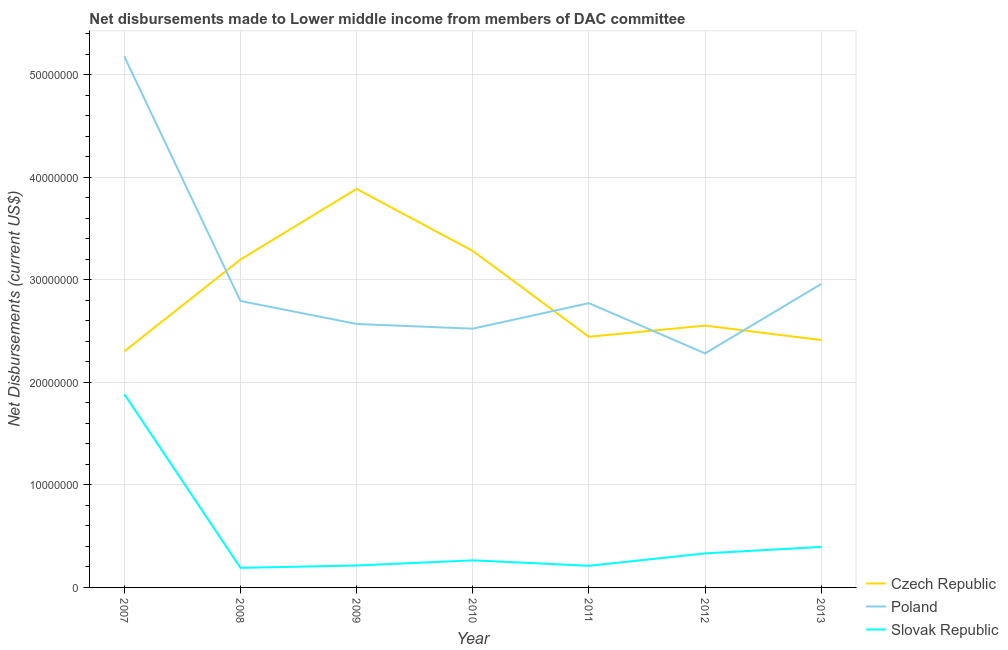Does the line corresponding to net disbursements made by poland intersect with the line corresponding to net disbursements made by slovak republic?
Ensure brevity in your answer.  No. Is the number of lines equal to the number of legend labels?
Ensure brevity in your answer.  Yes. What is the net disbursements made by slovak republic in 2012?
Provide a short and direct response. 3.32e+06. Across all years, what is the maximum net disbursements made by slovak republic?
Offer a very short reply. 1.88e+07. Across all years, what is the minimum net disbursements made by poland?
Ensure brevity in your answer.  2.28e+07. In which year was the net disbursements made by czech republic maximum?
Offer a very short reply. 2009. What is the total net disbursements made by poland in the graph?
Your answer should be compact. 2.11e+08. What is the difference between the net disbursements made by slovak republic in 2007 and that in 2011?
Keep it short and to the point. 1.67e+07. What is the difference between the net disbursements made by slovak republic in 2010 and the net disbursements made by poland in 2009?
Ensure brevity in your answer.  -2.30e+07. What is the average net disbursements made by slovak republic per year?
Your answer should be compact. 4.99e+06. In the year 2012, what is the difference between the net disbursements made by czech republic and net disbursements made by poland?
Make the answer very short. 2.71e+06. What is the ratio of the net disbursements made by czech republic in 2011 to that in 2012?
Your response must be concise. 0.96. Is the difference between the net disbursements made by poland in 2009 and 2012 greater than the difference between the net disbursements made by slovak republic in 2009 and 2012?
Offer a very short reply. Yes. What is the difference between the highest and the second highest net disbursements made by poland?
Ensure brevity in your answer.  2.22e+07. What is the difference between the highest and the lowest net disbursements made by czech republic?
Keep it short and to the point. 1.58e+07. In how many years, is the net disbursements made by czech republic greater than the average net disbursements made by czech republic taken over all years?
Offer a terse response. 3. Is it the case that in every year, the sum of the net disbursements made by czech republic and net disbursements made by poland is greater than the net disbursements made by slovak republic?
Offer a very short reply. Yes. Does the net disbursements made by poland monotonically increase over the years?
Provide a succinct answer. No. Is the net disbursements made by poland strictly greater than the net disbursements made by czech republic over the years?
Provide a succinct answer. No. Are the values on the major ticks of Y-axis written in scientific E-notation?
Provide a succinct answer. No. Does the graph contain grids?
Keep it short and to the point. Yes. What is the title of the graph?
Give a very brief answer. Net disbursements made to Lower middle income from members of DAC committee. What is the label or title of the X-axis?
Offer a terse response. Year. What is the label or title of the Y-axis?
Ensure brevity in your answer.  Net Disbursements (current US$). What is the Net Disbursements (current US$) of Czech Republic in 2007?
Your response must be concise. 2.30e+07. What is the Net Disbursements (current US$) in Poland in 2007?
Give a very brief answer. 5.18e+07. What is the Net Disbursements (current US$) in Slovak Republic in 2007?
Provide a succinct answer. 1.88e+07. What is the Net Disbursements (current US$) of Czech Republic in 2008?
Provide a short and direct response. 3.20e+07. What is the Net Disbursements (current US$) in Poland in 2008?
Provide a succinct answer. 2.79e+07. What is the Net Disbursements (current US$) of Slovak Republic in 2008?
Your answer should be very brief. 1.91e+06. What is the Net Disbursements (current US$) in Czech Republic in 2009?
Give a very brief answer. 3.89e+07. What is the Net Disbursements (current US$) of Poland in 2009?
Provide a succinct answer. 2.57e+07. What is the Net Disbursements (current US$) of Slovak Republic in 2009?
Your answer should be compact. 2.14e+06. What is the Net Disbursements (current US$) of Czech Republic in 2010?
Ensure brevity in your answer.  3.28e+07. What is the Net Disbursements (current US$) of Poland in 2010?
Provide a succinct answer. 2.52e+07. What is the Net Disbursements (current US$) in Slovak Republic in 2010?
Provide a short and direct response. 2.64e+06. What is the Net Disbursements (current US$) in Czech Republic in 2011?
Provide a succinct answer. 2.44e+07. What is the Net Disbursements (current US$) of Poland in 2011?
Your answer should be compact. 2.77e+07. What is the Net Disbursements (current US$) in Slovak Republic in 2011?
Make the answer very short. 2.11e+06. What is the Net Disbursements (current US$) in Czech Republic in 2012?
Your answer should be very brief. 2.55e+07. What is the Net Disbursements (current US$) of Poland in 2012?
Make the answer very short. 2.28e+07. What is the Net Disbursements (current US$) in Slovak Republic in 2012?
Provide a short and direct response. 3.32e+06. What is the Net Disbursements (current US$) in Czech Republic in 2013?
Give a very brief answer. 2.41e+07. What is the Net Disbursements (current US$) in Poland in 2013?
Make the answer very short. 2.96e+07. What is the Net Disbursements (current US$) in Slovak Republic in 2013?
Provide a short and direct response. 3.95e+06. Across all years, what is the maximum Net Disbursements (current US$) of Czech Republic?
Keep it short and to the point. 3.89e+07. Across all years, what is the maximum Net Disbursements (current US$) of Poland?
Offer a terse response. 5.18e+07. Across all years, what is the maximum Net Disbursements (current US$) of Slovak Republic?
Provide a short and direct response. 1.88e+07. Across all years, what is the minimum Net Disbursements (current US$) of Czech Republic?
Keep it short and to the point. 2.30e+07. Across all years, what is the minimum Net Disbursements (current US$) in Poland?
Your response must be concise. 2.28e+07. Across all years, what is the minimum Net Disbursements (current US$) in Slovak Republic?
Offer a terse response. 1.91e+06. What is the total Net Disbursements (current US$) of Czech Republic in the graph?
Offer a terse response. 2.01e+08. What is the total Net Disbursements (current US$) of Poland in the graph?
Provide a succinct answer. 2.11e+08. What is the total Net Disbursements (current US$) in Slovak Republic in the graph?
Ensure brevity in your answer.  3.49e+07. What is the difference between the Net Disbursements (current US$) in Czech Republic in 2007 and that in 2008?
Provide a short and direct response. -8.95e+06. What is the difference between the Net Disbursements (current US$) of Poland in 2007 and that in 2008?
Ensure brevity in your answer.  2.38e+07. What is the difference between the Net Disbursements (current US$) of Slovak Republic in 2007 and that in 2008?
Provide a short and direct response. 1.69e+07. What is the difference between the Net Disbursements (current US$) in Czech Republic in 2007 and that in 2009?
Ensure brevity in your answer.  -1.58e+07. What is the difference between the Net Disbursements (current US$) in Poland in 2007 and that in 2009?
Your answer should be very brief. 2.61e+07. What is the difference between the Net Disbursements (current US$) of Slovak Republic in 2007 and that in 2009?
Your response must be concise. 1.67e+07. What is the difference between the Net Disbursements (current US$) of Czech Republic in 2007 and that in 2010?
Offer a terse response. -9.79e+06. What is the difference between the Net Disbursements (current US$) in Poland in 2007 and that in 2010?
Give a very brief answer. 2.66e+07. What is the difference between the Net Disbursements (current US$) of Slovak Republic in 2007 and that in 2010?
Give a very brief answer. 1.62e+07. What is the difference between the Net Disbursements (current US$) of Czech Republic in 2007 and that in 2011?
Provide a short and direct response. -1.42e+06. What is the difference between the Net Disbursements (current US$) of Poland in 2007 and that in 2011?
Offer a very short reply. 2.41e+07. What is the difference between the Net Disbursements (current US$) in Slovak Republic in 2007 and that in 2011?
Ensure brevity in your answer.  1.67e+07. What is the difference between the Net Disbursements (current US$) in Czech Republic in 2007 and that in 2012?
Ensure brevity in your answer.  -2.51e+06. What is the difference between the Net Disbursements (current US$) in Poland in 2007 and that in 2012?
Ensure brevity in your answer.  2.90e+07. What is the difference between the Net Disbursements (current US$) of Slovak Republic in 2007 and that in 2012?
Your answer should be very brief. 1.55e+07. What is the difference between the Net Disbursements (current US$) of Czech Republic in 2007 and that in 2013?
Give a very brief answer. -1.10e+06. What is the difference between the Net Disbursements (current US$) in Poland in 2007 and that in 2013?
Provide a short and direct response. 2.22e+07. What is the difference between the Net Disbursements (current US$) of Slovak Republic in 2007 and that in 2013?
Provide a succinct answer. 1.49e+07. What is the difference between the Net Disbursements (current US$) in Czech Republic in 2008 and that in 2009?
Your answer should be compact. -6.89e+06. What is the difference between the Net Disbursements (current US$) in Poland in 2008 and that in 2009?
Provide a short and direct response. 2.24e+06. What is the difference between the Net Disbursements (current US$) in Slovak Republic in 2008 and that in 2009?
Your answer should be compact. -2.30e+05. What is the difference between the Net Disbursements (current US$) in Czech Republic in 2008 and that in 2010?
Keep it short and to the point. -8.40e+05. What is the difference between the Net Disbursements (current US$) of Poland in 2008 and that in 2010?
Your answer should be very brief. 2.70e+06. What is the difference between the Net Disbursements (current US$) in Slovak Republic in 2008 and that in 2010?
Give a very brief answer. -7.30e+05. What is the difference between the Net Disbursements (current US$) of Czech Republic in 2008 and that in 2011?
Offer a very short reply. 7.53e+06. What is the difference between the Net Disbursements (current US$) in Czech Republic in 2008 and that in 2012?
Ensure brevity in your answer.  6.44e+06. What is the difference between the Net Disbursements (current US$) of Poland in 2008 and that in 2012?
Offer a terse response. 5.11e+06. What is the difference between the Net Disbursements (current US$) of Slovak Republic in 2008 and that in 2012?
Offer a very short reply. -1.41e+06. What is the difference between the Net Disbursements (current US$) of Czech Republic in 2008 and that in 2013?
Provide a succinct answer. 7.85e+06. What is the difference between the Net Disbursements (current US$) in Poland in 2008 and that in 2013?
Make the answer very short. -1.66e+06. What is the difference between the Net Disbursements (current US$) of Slovak Republic in 2008 and that in 2013?
Your answer should be very brief. -2.04e+06. What is the difference between the Net Disbursements (current US$) in Czech Republic in 2009 and that in 2010?
Ensure brevity in your answer.  6.05e+06. What is the difference between the Net Disbursements (current US$) in Poland in 2009 and that in 2010?
Ensure brevity in your answer.  4.60e+05. What is the difference between the Net Disbursements (current US$) in Slovak Republic in 2009 and that in 2010?
Give a very brief answer. -5.00e+05. What is the difference between the Net Disbursements (current US$) of Czech Republic in 2009 and that in 2011?
Provide a succinct answer. 1.44e+07. What is the difference between the Net Disbursements (current US$) of Poland in 2009 and that in 2011?
Make the answer very short. -2.03e+06. What is the difference between the Net Disbursements (current US$) in Slovak Republic in 2009 and that in 2011?
Provide a short and direct response. 3.00e+04. What is the difference between the Net Disbursements (current US$) of Czech Republic in 2009 and that in 2012?
Offer a terse response. 1.33e+07. What is the difference between the Net Disbursements (current US$) in Poland in 2009 and that in 2012?
Offer a terse response. 2.87e+06. What is the difference between the Net Disbursements (current US$) of Slovak Republic in 2009 and that in 2012?
Provide a short and direct response. -1.18e+06. What is the difference between the Net Disbursements (current US$) in Czech Republic in 2009 and that in 2013?
Offer a very short reply. 1.47e+07. What is the difference between the Net Disbursements (current US$) in Poland in 2009 and that in 2013?
Your answer should be compact. -3.90e+06. What is the difference between the Net Disbursements (current US$) in Slovak Republic in 2009 and that in 2013?
Your answer should be very brief. -1.81e+06. What is the difference between the Net Disbursements (current US$) in Czech Republic in 2010 and that in 2011?
Offer a very short reply. 8.37e+06. What is the difference between the Net Disbursements (current US$) in Poland in 2010 and that in 2011?
Give a very brief answer. -2.49e+06. What is the difference between the Net Disbursements (current US$) of Slovak Republic in 2010 and that in 2011?
Keep it short and to the point. 5.30e+05. What is the difference between the Net Disbursements (current US$) of Czech Republic in 2010 and that in 2012?
Your answer should be very brief. 7.28e+06. What is the difference between the Net Disbursements (current US$) in Poland in 2010 and that in 2012?
Your response must be concise. 2.41e+06. What is the difference between the Net Disbursements (current US$) of Slovak Republic in 2010 and that in 2012?
Ensure brevity in your answer.  -6.80e+05. What is the difference between the Net Disbursements (current US$) of Czech Republic in 2010 and that in 2013?
Offer a terse response. 8.69e+06. What is the difference between the Net Disbursements (current US$) of Poland in 2010 and that in 2013?
Your answer should be very brief. -4.36e+06. What is the difference between the Net Disbursements (current US$) of Slovak Republic in 2010 and that in 2013?
Ensure brevity in your answer.  -1.31e+06. What is the difference between the Net Disbursements (current US$) in Czech Republic in 2011 and that in 2012?
Keep it short and to the point. -1.09e+06. What is the difference between the Net Disbursements (current US$) in Poland in 2011 and that in 2012?
Offer a very short reply. 4.90e+06. What is the difference between the Net Disbursements (current US$) of Slovak Republic in 2011 and that in 2012?
Offer a terse response. -1.21e+06. What is the difference between the Net Disbursements (current US$) in Poland in 2011 and that in 2013?
Give a very brief answer. -1.87e+06. What is the difference between the Net Disbursements (current US$) of Slovak Republic in 2011 and that in 2013?
Ensure brevity in your answer.  -1.84e+06. What is the difference between the Net Disbursements (current US$) of Czech Republic in 2012 and that in 2013?
Ensure brevity in your answer.  1.41e+06. What is the difference between the Net Disbursements (current US$) in Poland in 2012 and that in 2013?
Provide a succinct answer. -6.77e+06. What is the difference between the Net Disbursements (current US$) of Slovak Republic in 2012 and that in 2013?
Ensure brevity in your answer.  -6.30e+05. What is the difference between the Net Disbursements (current US$) in Czech Republic in 2007 and the Net Disbursements (current US$) in Poland in 2008?
Offer a very short reply. -4.91e+06. What is the difference between the Net Disbursements (current US$) of Czech Republic in 2007 and the Net Disbursements (current US$) of Slovak Republic in 2008?
Your answer should be compact. 2.11e+07. What is the difference between the Net Disbursements (current US$) in Poland in 2007 and the Net Disbursements (current US$) in Slovak Republic in 2008?
Your response must be concise. 4.99e+07. What is the difference between the Net Disbursements (current US$) of Czech Republic in 2007 and the Net Disbursements (current US$) of Poland in 2009?
Provide a succinct answer. -2.67e+06. What is the difference between the Net Disbursements (current US$) in Czech Republic in 2007 and the Net Disbursements (current US$) in Slovak Republic in 2009?
Give a very brief answer. 2.09e+07. What is the difference between the Net Disbursements (current US$) of Poland in 2007 and the Net Disbursements (current US$) of Slovak Republic in 2009?
Offer a very short reply. 4.96e+07. What is the difference between the Net Disbursements (current US$) of Czech Republic in 2007 and the Net Disbursements (current US$) of Poland in 2010?
Your response must be concise. -2.21e+06. What is the difference between the Net Disbursements (current US$) of Czech Republic in 2007 and the Net Disbursements (current US$) of Slovak Republic in 2010?
Your answer should be very brief. 2.04e+07. What is the difference between the Net Disbursements (current US$) of Poland in 2007 and the Net Disbursements (current US$) of Slovak Republic in 2010?
Your response must be concise. 4.91e+07. What is the difference between the Net Disbursements (current US$) in Czech Republic in 2007 and the Net Disbursements (current US$) in Poland in 2011?
Your response must be concise. -4.70e+06. What is the difference between the Net Disbursements (current US$) of Czech Republic in 2007 and the Net Disbursements (current US$) of Slovak Republic in 2011?
Keep it short and to the point. 2.09e+07. What is the difference between the Net Disbursements (current US$) in Poland in 2007 and the Net Disbursements (current US$) in Slovak Republic in 2011?
Ensure brevity in your answer.  4.97e+07. What is the difference between the Net Disbursements (current US$) in Czech Republic in 2007 and the Net Disbursements (current US$) in Poland in 2012?
Ensure brevity in your answer.  2.00e+05. What is the difference between the Net Disbursements (current US$) of Czech Republic in 2007 and the Net Disbursements (current US$) of Slovak Republic in 2012?
Your answer should be compact. 1.97e+07. What is the difference between the Net Disbursements (current US$) in Poland in 2007 and the Net Disbursements (current US$) in Slovak Republic in 2012?
Keep it short and to the point. 4.85e+07. What is the difference between the Net Disbursements (current US$) of Czech Republic in 2007 and the Net Disbursements (current US$) of Poland in 2013?
Make the answer very short. -6.57e+06. What is the difference between the Net Disbursements (current US$) in Czech Republic in 2007 and the Net Disbursements (current US$) in Slovak Republic in 2013?
Your answer should be very brief. 1.91e+07. What is the difference between the Net Disbursements (current US$) of Poland in 2007 and the Net Disbursements (current US$) of Slovak Republic in 2013?
Keep it short and to the point. 4.78e+07. What is the difference between the Net Disbursements (current US$) in Czech Republic in 2008 and the Net Disbursements (current US$) in Poland in 2009?
Provide a short and direct response. 6.28e+06. What is the difference between the Net Disbursements (current US$) of Czech Republic in 2008 and the Net Disbursements (current US$) of Slovak Republic in 2009?
Offer a terse response. 2.98e+07. What is the difference between the Net Disbursements (current US$) in Poland in 2008 and the Net Disbursements (current US$) in Slovak Republic in 2009?
Make the answer very short. 2.58e+07. What is the difference between the Net Disbursements (current US$) in Czech Republic in 2008 and the Net Disbursements (current US$) in Poland in 2010?
Your response must be concise. 6.74e+06. What is the difference between the Net Disbursements (current US$) in Czech Republic in 2008 and the Net Disbursements (current US$) in Slovak Republic in 2010?
Offer a very short reply. 2.93e+07. What is the difference between the Net Disbursements (current US$) of Poland in 2008 and the Net Disbursements (current US$) of Slovak Republic in 2010?
Provide a succinct answer. 2.53e+07. What is the difference between the Net Disbursements (current US$) in Czech Republic in 2008 and the Net Disbursements (current US$) in Poland in 2011?
Your response must be concise. 4.25e+06. What is the difference between the Net Disbursements (current US$) in Czech Republic in 2008 and the Net Disbursements (current US$) in Slovak Republic in 2011?
Offer a terse response. 2.99e+07. What is the difference between the Net Disbursements (current US$) in Poland in 2008 and the Net Disbursements (current US$) in Slovak Republic in 2011?
Offer a terse response. 2.58e+07. What is the difference between the Net Disbursements (current US$) of Czech Republic in 2008 and the Net Disbursements (current US$) of Poland in 2012?
Offer a very short reply. 9.15e+06. What is the difference between the Net Disbursements (current US$) of Czech Republic in 2008 and the Net Disbursements (current US$) of Slovak Republic in 2012?
Your answer should be very brief. 2.86e+07. What is the difference between the Net Disbursements (current US$) of Poland in 2008 and the Net Disbursements (current US$) of Slovak Republic in 2012?
Your response must be concise. 2.46e+07. What is the difference between the Net Disbursements (current US$) in Czech Republic in 2008 and the Net Disbursements (current US$) in Poland in 2013?
Ensure brevity in your answer.  2.38e+06. What is the difference between the Net Disbursements (current US$) of Czech Republic in 2008 and the Net Disbursements (current US$) of Slovak Republic in 2013?
Provide a succinct answer. 2.80e+07. What is the difference between the Net Disbursements (current US$) in Poland in 2008 and the Net Disbursements (current US$) in Slovak Republic in 2013?
Keep it short and to the point. 2.40e+07. What is the difference between the Net Disbursements (current US$) in Czech Republic in 2009 and the Net Disbursements (current US$) in Poland in 2010?
Make the answer very short. 1.36e+07. What is the difference between the Net Disbursements (current US$) of Czech Republic in 2009 and the Net Disbursements (current US$) of Slovak Republic in 2010?
Provide a succinct answer. 3.62e+07. What is the difference between the Net Disbursements (current US$) of Poland in 2009 and the Net Disbursements (current US$) of Slovak Republic in 2010?
Keep it short and to the point. 2.30e+07. What is the difference between the Net Disbursements (current US$) of Czech Republic in 2009 and the Net Disbursements (current US$) of Poland in 2011?
Your answer should be compact. 1.11e+07. What is the difference between the Net Disbursements (current US$) in Czech Republic in 2009 and the Net Disbursements (current US$) in Slovak Republic in 2011?
Your answer should be very brief. 3.68e+07. What is the difference between the Net Disbursements (current US$) of Poland in 2009 and the Net Disbursements (current US$) of Slovak Republic in 2011?
Your response must be concise. 2.36e+07. What is the difference between the Net Disbursements (current US$) of Czech Republic in 2009 and the Net Disbursements (current US$) of Poland in 2012?
Provide a short and direct response. 1.60e+07. What is the difference between the Net Disbursements (current US$) of Czech Republic in 2009 and the Net Disbursements (current US$) of Slovak Republic in 2012?
Your response must be concise. 3.55e+07. What is the difference between the Net Disbursements (current US$) in Poland in 2009 and the Net Disbursements (current US$) in Slovak Republic in 2012?
Ensure brevity in your answer.  2.24e+07. What is the difference between the Net Disbursements (current US$) of Czech Republic in 2009 and the Net Disbursements (current US$) of Poland in 2013?
Give a very brief answer. 9.27e+06. What is the difference between the Net Disbursements (current US$) in Czech Republic in 2009 and the Net Disbursements (current US$) in Slovak Republic in 2013?
Your response must be concise. 3.49e+07. What is the difference between the Net Disbursements (current US$) in Poland in 2009 and the Net Disbursements (current US$) in Slovak Republic in 2013?
Provide a short and direct response. 2.17e+07. What is the difference between the Net Disbursements (current US$) in Czech Republic in 2010 and the Net Disbursements (current US$) in Poland in 2011?
Provide a short and direct response. 5.09e+06. What is the difference between the Net Disbursements (current US$) in Czech Republic in 2010 and the Net Disbursements (current US$) in Slovak Republic in 2011?
Offer a very short reply. 3.07e+07. What is the difference between the Net Disbursements (current US$) in Poland in 2010 and the Net Disbursements (current US$) in Slovak Republic in 2011?
Provide a succinct answer. 2.31e+07. What is the difference between the Net Disbursements (current US$) of Czech Republic in 2010 and the Net Disbursements (current US$) of Poland in 2012?
Provide a short and direct response. 9.99e+06. What is the difference between the Net Disbursements (current US$) in Czech Republic in 2010 and the Net Disbursements (current US$) in Slovak Republic in 2012?
Offer a terse response. 2.95e+07. What is the difference between the Net Disbursements (current US$) in Poland in 2010 and the Net Disbursements (current US$) in Slovak Republic in 2012?
Provide a short and direct response. 2.19e+07. What is the difference between the Net Disbursements (current US$) of Czech Republic in 2010 and the Net Disbursements (current US$) of Poland in 2013?
Your answer should be very brief. 3.22e+06. What is the difference between the Net Disbursements (current US$) in Czech Republic in 2010 and the Net Disbursements (current US$) in Slovak Republic in 2013?
Your response must be concise. 2.89e+07. What is the difference between the Net Disbursements (current US$) in Poland in 2010 and the Net Disbursements (current US$) in Slovak Republic in 2013?
Make the answer very short. 2.13e+07. What is the difference between the Net Disbursements (current US$) in Czech Republic in 2011 and the Net Disbursements (current US$) in Poland in 2012?
Your response must be concise. 1.62e+06. What is the difference between the Net Disbursements (current US$) in Czech Republic in 2011 and the Net Disbursements (current US$) in Slovak Republic in 2012?
Provide a short and direct response. 2.11e+07. What is the difference between the Net Disbursements (current US$) in Poland in 2011 and the Net Disbursements (current US$) in Slovak Republic in 2012?
Your answer should be very brief. 2.44e+07. What is the difference between the Net Disbursements (current US$) in Czech Republic in 2011 and the Net Disbursements (current US$) in Poland in 2013?
Offer a very short reply. -5.15e+06. What is the difference between the Net Disbursements (current US$) of Czech Republic in 2011 and the Net Disbursements (current US$) of Slovak Republic in 2013?
Your response must be concise. 2.05e+07. What is the difference between the Net Disbursements (current US$) in Poland in 2011 and the Net Disbursements (current US$) in Slovak Republic in 2013?
Make the answer very short. 2.38e+07. What is the difference between the Net Disbursements (current US$) of Czech Republic in 2012 and the Net Disbursements (current US$) of Poland in 2013?
Ensure brevity in your answer.  -4.06e+06. What is the difference between the Net Disbursements (current US$) of Czech Republic in 2012 and the Net Disbursements (current US$) of Slovak Republic in 2013?
Ensure brevity in your answer.  2.16e+07. What is the difference between the Net Disbursements (current US$) of Poland in 2012 and the Net Disbursements (current US$) of Slovak Republic in 2013?
Your answer should be compact. 1.89e+07. What is the average Net Disbursements (current US$) in Czech Republic per year?
Make the answer very short. 2.87e+07. What is the average Net Disbursements (current US$) of Poland per year?
Provide a succinct answer. 3.01e+07. What is the average Net Disbursements (current US$) of Slovak Republic per year?
Your answer should be compact. 4.99e+06. In the year 2007, what is the difference between the Net Disbursements (current US$) of Czech Republic and Net Disbursements (current US$) of Poland?
Make the answer very short. -2.88e+07. In the year 2007, what is the difference between the Net Disbursements (current US$) in Czech Republic and Net Disbursements (current US$) in Slovak Republic?
Your answer should be very brief. 4.17e+06. In the year 2007, what is the difference between the Net Disbursements (current US$) in Poland and Net Disbursements (current US$) in Slovak Republic?
Provide a short and direct response. 3.29e+07. In the year 2008, what is the difference between the Net Disbursements (current US$) of Czech Republic and Net Disbursements (current US$) of Poland?
Your answer should be compact. 4.04e+06. In the year 2008, what is the difference between the Net Disbursements (current US$) of Czech Republic and Net Disbursements (current US$) of Slovak Republic?
Offer a very short reply. 3.01e+07. In the year 2008, what is the difference between the Net Disbursements (current US$) of Poland and Net Disbursements (current US$) of Slovak Republic?
Provide a short and direct response. 2.60e+07. In the year 2009, what is the difference between the Net Disbursements (current US$) of Czech Republic and Net Disbursements (current US$) of Poland?
Your answer should be very brief. 1.32e+07. In the year 2009, what is the difference between the Net Disbursements (current US$) of Czech Republic and Net Disbursements (current US$) of Slovak Republic?
Keep it short and to the point. 3.67e+07. In the year 2009, what is the difference between the Net Disbursements (current US$) of Poland and Net Disbursements (current US$) of Slovak Republic?
Your answer should be very brief. 2.36e+07. In the year 2010, what is the difference between the Net Disbursements (current US$) of Czech Republic and Net Disbursements (current US$) of Poland?
Give a very brief answer. 7.58e+06. In the year 2010, what is the difference between the Net Disbursements (current US$) in Czech Republic and Net Disbursements (current US$) in Slovak Republic?
Ensure brevity in your answer.  3.02e+07. In the year 2010, what is the difference between the Net Disbursements (current US$) in Poland and Net Disbursements (current US$) in Slovak Republic?
Your answer should be very brief. 2.26e+07. In the year 2011, what is the difference between the Net Disbursements (current US$) of Czech Republic and Net Disbursements (current US$) of Poland?
Provide a short and direct response. -3.28e+06. In the year 2011, what is the difference between the Net Disbursements (current US$) of Czech Republic and Net Disbursements (current US$) of Slovak Republic?
Provide a short and direct response. 2.23e+07. In the year 2011, what is the difference between the Net Disbursements (current US$) in Poland and Net Disbursements (current US$) in Slovak Republic?
Keep it short and to the point. 2.56e+07. In the year 2012, what is the difference between the Net Disbursements (current US$) in Czech Republic and Net Disbursements (current US$) in Poland?
Ensure brevity in your answer.  2.71e+06. In the year 2012, what is the difference between the Net Disbursements (current US$) of Czech Republic and Net Disbursements (current US$) of Slovak Republic?
Keep it short and to the point. 2.22e+07. In the year 2012, what is the difference between the Net Disbursements (current US$) of Poland and Net Disbursements (current US$) of Slovak Republic?
Offer a terse response. 1.95e+07. In the year 2013, what is the difference between the Net Disbursements (current US$) in Czech Republic and Net Disbursements (current US$) in Poland?
Provide a succinct answer. -5.47e+06. In the year 2013, what is the difference between the Net Disbursements (current US$) in Czech Republic and Net Disbursements (current US$) in Slovak Republic?
Offer a very short reply. 2.02e+07. In the year 2013, what is the difference between the Net Disbursements (current US$) in Poland and Net Disbursements (current US$) in Slovak Republic?
Ensure brevity in your answer.  2.56e+07. What is the ratio of the Net Disbursements (current US$) of Czech Republic in 2007 to that in 2008?
Provide a short and direct response. 0.72. What is the ratio of the Net Disbursements (current US$) of Poland in 2007 to that in 2008?
Your response must be concise. 1.85. What is the ratio of the Net Disbursements (current US$) in Slovak Republic in 2007 to that in 2008?
Your answer should be very brief. 9.87. What is the ratio of the Net Disbursements (current US$) of Czech Republic in 2007 to that in 2009?
Your answer should be compact. 0.59. What is the ratio of the Net Disbursements (current US$) in Poland in 2007 to that in 2009?
Your answer should be very brief. 2.02. What is the ratio of the Net Disbursements (current US$) in Slovak Republic in 2007 to that in 2009?
Your answer should be very brief. 8.81. What is the ratio of the Net Disbursements (current US$) in Czech Republic in 2007 to that in 2010?
Your response must be concise. 0.7. What is the ratio of the Net Disbursements (current US$) of Poland in 2007 to that in 2010?
Keep it short and to the point. 2.05. What is the ratio of the Net Disbursements (current US$) of Slovak Republic in 2007 to that in 2010?
Give a very brief answer. 7.14. What is the ratio of the Net Disbursements (current US$) in Czech Republic in 2007 to that in 2011?
Your answer should be very brief. 0.94. What is the ratio of the Net Disbursements (current US$) in Poland in 2007 to that in 2011?
Provide a succinct answer. 1.87. What is the ratio of the Net Disbursements (current US$) in Slovak Republic in 2007 to that in 2011?
Give a very brief answer. 8.93. What is the ratio of the Net Disbursements (current US$) in Czech Republic in 2007 to that in 2012?
Keep it short and to the point. 0.9. What is the ratio of the Net Disbursements (current US$) in Poland in 2007 to that in 2012?
Your answer should be compact. 2.27. What is the ratio of the Net Disbursements (current US$) of Slovak Republic in 2007 to that in 2012?
Your answer should be compact. 5.68. What is the ratio of the Net Disbursements (current US$) of Czech Republic in 2007 to that in 2013?
Your answer should be compact. 0.95. What is the ratio of the Net Disbursements (current US$) of Poland in 2007 to that in 2013?
Ensure brevity in your answer.  1.75. What is the ratio of the Net Disbursements (current US$) of Slovak Republic in 2007 to that in 2013?
Keep it short and to the point. 4.77. What is the ratio of the Net Disbursements (current US$) in Czech Republic in 2008 to that in 2009?
Your answer should be very brief. 0.82. What is the ratio of the Net Disbursements (current US$) in Poland in 2008 to that in 2009?
Offer a terse response. 1.09. What is the ratio of the Net Disbursements (current US$) of Slovak Republic in 2008 to that in 2009?
Ensure brevity in your answer.  0.89. What is the ratio of the Net Disbursements (current US$) of Czech Republic in 2008 to that in 2010?
Your answer should be compact. 0.97. What is the ratio of the Net Disbursements (current US$) in Poland in 2008 to that in 2010?
Offer a very short reply. 1.11. What is the ratio of the Net Disbursements (current US$) in Slovak Republic in 2008 to that in 2010?
Your answer should be very brief. 0.72. What is the ratio of the Net Disbursements (current US$) in Czech Republic in 2008 to that in 2011?
Make the answer very short. 1.31. What is the ratio of the Net Disbursements (current US$) of Poland in 2008 to that in 2011?
Offer a terse response. 1.01. What is the ratio of the Net Disbursements (current US$) of Slovak Republic in 2008 to that in 2011?
Provide a succinct answer. 0.91. What is the ratio of the Net Disbursements (current US$) of Czech Republic in 2008 to that in 2012?
Provide a short and direct response. 1.25. What is the ratio of the Net Disbursements (current US$) of Poland in 2008 to that in 2012?
Your answer should be very brief. 1.22. What is the ratio of the Net Disbursements (current US$) in Slovak Republic in 2008 to that in 2012?
Give a very brief answer. 0.58. What is the ratio of the Net Disbursements (current US$) of Czech Republic in 2008 to that in 2013?
Your answer should be very brief. 1.33. What is the ratio of the Net Disbursements (current US$) of Poland in 2008 to that in 2013?
Provide a succinct answer. 0.94. What is the ratio of the Net Disbursements (current US$) of Slovak Republic in 2008 to that in 2013?
Keep it short and to the point. 0.48. What is the ratio of the Net Disbursements (current US$) in Czech Republic in 2009 to that in 2010?
Give a very brief answer. 1.18. What is the ratio of the Net Disbursements (current US$) in Poland in 2009 to that in 2010?
Keep it short and to the point. 1.02. What is the ratio of the Net Disbursements (current US$) in Slovak Republic in 2009 to that in 2010?
Your response must be concise. 0.81. What is the ratio of the Net Disbursements (current US$) in Czech Republic in 2009 to that in 2011?
Offer a very short reply. 1.59. What is the ratio of the Net Disbursements (current US$) of Poland in 2009 to that in 2011?
Provide a succinct answer. 0.93. What is the ratio of the Net Disbursements (current US$) in Slovak Republic in 2009 to that in 2011?
Provide a short and direct response. 1.01. What is the ratio of the Net Disbursements (current US$) in Czech Republic in 2009 to that in 2012?
Your answer should be very brief. 1.52. What is the ratio of the Net Disbursements (current US$) of Poland in 2009 to that in 2012?
Provide a succinct answer. 1.13. What is the ratio of the Net Disbursements (current US$) of Slovak Republic in 2009 to that in 2012?
Provide a succinct answer. 0.64. What is the ratio of the Net Disbursements (current US$) of Czech Republic in 2009 to that in 2013?
Provide a succinct answer. 1.61. What is the ratio of the Net Disbursements (current US$) of Poland in 2009 to that in 2013?
Ensure brevity in your answer.  0.87. What is the ratio of the Net Disbursements (current US$) in Slovak Republic in 2009 to that in 2013?
Offer a terse response. 0.54. What is the ratio of the Net Disbursements (current US$) of Czech Republic in 2010 to that in 2011?
Keep it short and to the point. 1.34. What is the ratio of the Net Disbursements (current US$) of Poland in 2010 to that in 2011?
Give a very brief answer. 0.91. What is the ratio of the Net Disbursements (current US$) in Slovak Republic in 2010 to that in 2011?
Keep it short and to the point. 1.25. What is the ratio of the Net Disbursements (current US$) of Czech Republic in 2010 to that in 2012?
Provide a succinct answer. 1.29. What is the ratio of the Net Disbursements (current US$) of Poland in 2010 to that in 2012?
Make the answer very short. 1.11. What is the ratio of the Net Disbursements (current US$) of Slovak Republic in 2010 to that in 2012?
Provide a short and direct response. 0.8. What is the ratio of the Net Disbursements (current US$) of Czech Republic in 2010 to that in 2013?
Your answer should be very brief. 1.36. What is the ratio of the Net Disbursements (current US$) in Poland in 2010 to that in 2013?
Offer a very short reply. 0.85. What is the ratio of the Net Disbursements (current US$) in Slovak Republic in 2010 to that in 2013?
Offer a terse response. 0.67. What is the ratio of the Net Disbursements (current US$) of Czech Republic in 2011 to that in 2012?
Your answer should be compact. 0.96. What is the ratio of the Net Disbursements (current US$) in Poland in 2011 to that in 2012?
Give a very brief answer. 1.21. What is the ratio of the Net Disbursements (current US$) in Slovak Republic in 2011 to that in 2012?
Offer a very short reply. 0.64. What is the ratio of the Net Disbursements (current US$) in Czech Republic in 2011 to that in 2013?
Give a very brief answer. 1.01. What is the ratio of the Net Disbursements (current US$) in Poland in 2011 to that in 2013?
Give a very brief answer. 0.94. What is the ratio of the Net Disbursements (current US$) in Slovak Republic in 2011 to that in 2013?
Make the answer very short. 0.53. What is the ratio of the Net Disbursements (current US$) in Czech Republic in 2012 to that in 2013?
Provide a succinct answer. 1.06. What is the ratio of the Net Disbursements (current US$) in Poland in 2012 to that in 2013?
Your response must be concise. 0.77. What is the ratio of the Net Disbursements (current US$) of Slovak Republic in 2012 to that in 2013?
Offer a very short reply. 0.84. What is the difference between the highest and the second highest Net Disbursements (current US$) in Czech Republic?
Offer a very short reply. 6.05e+06. What is the difference between the highest and the second highest Net Disbursements (current US$) of Poland?
Make the answer very short. 2.22e+07. What is the difference between the highest and the second highest Net Disbursements (current US$) of Slovak Republic?
Give a very brief answer. 1.49e+07. What is the difference between the highest and the lowest Net Disbursements (current US$) of Czech Republic?
Give a very brief answer. 1.58e+07. What is the difference between the highest and the lowest Net Disbursements (current US$) of Poland?
Provide a succinct answer. 2.90e+07. What is the difference between the highest and the lowest Net Disbursements (current US$) of Slovak Republic?
Provide a succinct answer. 1.69e+07. 